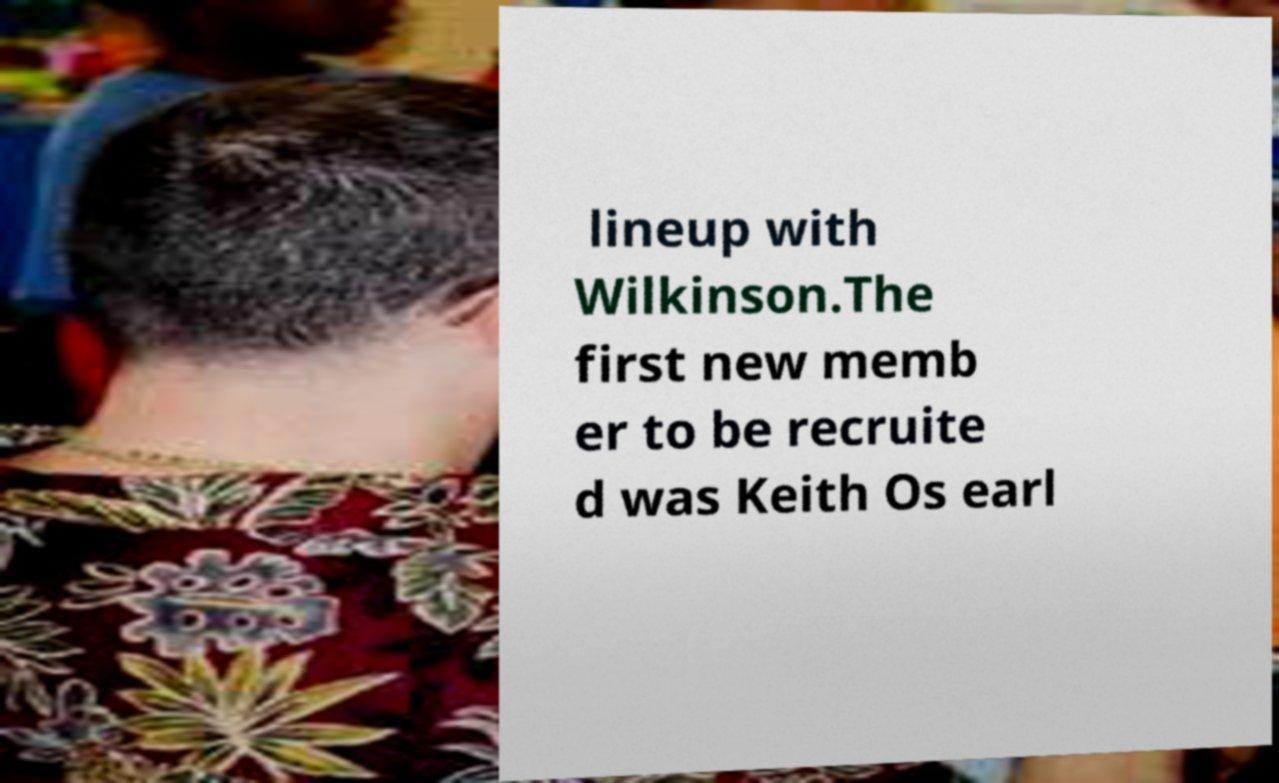Can you read and provide the text displayed in the image?This photo seems to have some interesting text. Can you extract and type it out for me? lineup with Wilkinson.The first new memb er to be recruite d was Keith Os earl 